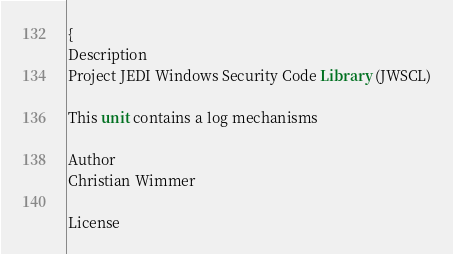Convert code to text. <code><loc_0><loc_0><loc_500><loc_500><_Pascal_>{
Description
Project JEDI Windows Security Code Library (JWSCL)

This unit contains a log mechanisms

Author
Christian Wimmer

License</code> 